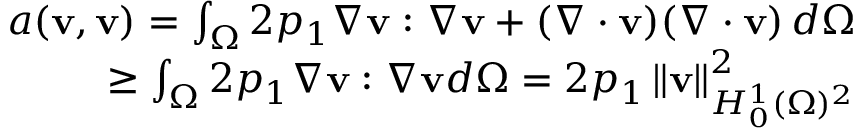<formula> <loc_0><loc_0><loc_500><loc_500>\begin{array} { r l r } & { a ( v , v ) = \int _ { \Omega } 2 p _ { 1 } \nabla v \colon \nabla v + ( \nabla \cdot v ) ( \nabla \cdot v ) \, d \Omega } \\ & { \geq \int _ { \Omega } 2 p _ { 1 } \nabla v \colon \nabla v d \Omega = 2 p _ { 1 } \left \| v \right \| _ { H _ { 0 } ^ { 1 } ( \Omega ) ^ { 2 } } ^ { 2 } } \end{array}</formula> 